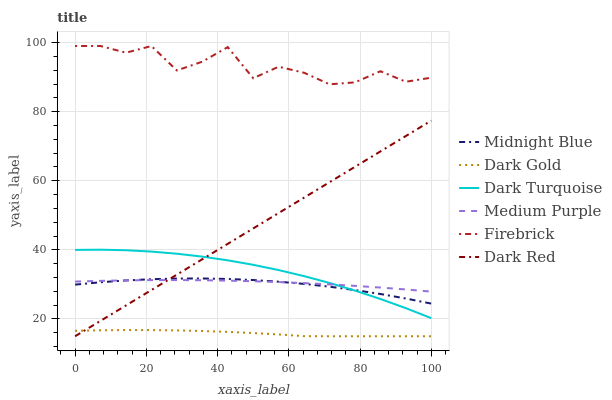Does Dark Gold have the minimum area under the curve?
Answer yes or no. Yes. Does Firebrick have the maximum area under the curve?
Answer yes or no. Yes. Does Dark Turquoise have the minimum area under the curve?
Answer yes or no. No. Does Dark Turquoise have the maximum area under the curve?
Answer yes or no. No. Is Dark Red the smoothest?
Answer yes or no. Yes. Is Firebrick the roughest?
Answer yes or no. Yes. Is Dark Gold the smoothest?
Answer yes or no. No. Is Dark Gold the roughest?
Answer yes or no. No. Does Dark Turquoise have the lowest value?
Answer yes or no. No. Does Firebrick have the highest value?
Answer yes or no. Yes. Does Dark Turquoise have the highest value?
Answer yes or no. No. Is Dark Gold less than Dark Turquoise?
Answer yes or no. Yes. Is Medium Purple greater than Dark Gold?
Answer yes or no. Yes. Does Dark Red intersect Dark Turquoise?
Answer yes or no. Yes. Is Dark Red less than Dark Turquoise?
Answer yes or no. No. Is Dark Red greater than Dark Turquoise?
Answer yes or no. No. Does Dark Gold intersect Dark Turquoise?
Answer yes or no. No. 